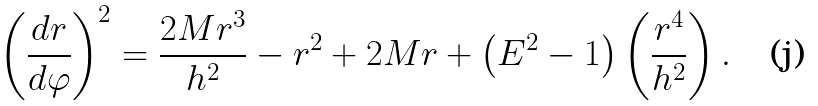Convert formula to latex. <formula><loc_0><loc_0><loc_500><loc_500>\left ( \frac { d r } { d \varphi } \right ) ^ { 2 } = \frac { 2 M r ^ { 3 } } { h ^ { 2 } } - r ^ { 2 } + 2 M r + \left ( E ^ { 2 } - 1 \right ) \left ( \frac { r ^ { 4 } } { h ^ { 2 } } \right ) .</formula> 